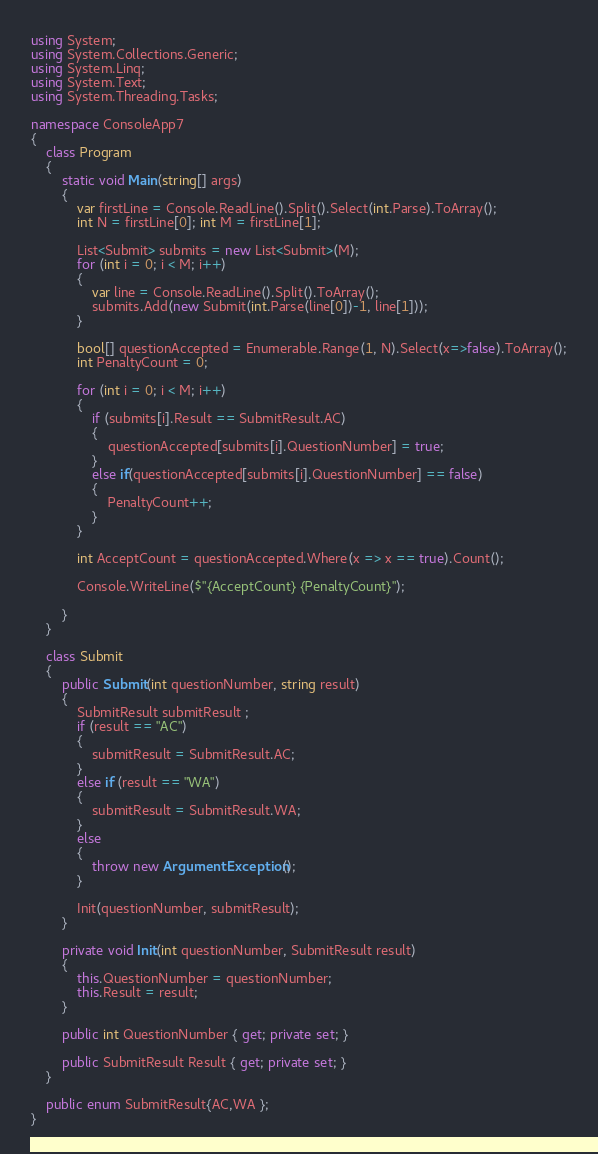<code> <loc_0><loc_0><loc_500><loc_500><_C#_>using System;
using System.Collections.Generic;
using System.Linq;
using System.Text;
using System.Threading.Tasks;

namespace ConsoleApp7
{
    class Program
    {
        static void Main(string[] args)
        {
            var firstLine = Console.ReadLine().Split().Select(int.Parse).ToArray();
            int N = firstLine[0]; int M = firstLine[1];

            List<Submit> submits = new List<Submit>(M);
            for (int i = 0; i < M; i++)
            {
                var line = Console.ReadLine().Split().ToArray();
                submits.Add(new Submit(int.Parse(line[0])-1, line[1]));
            }

            bool[] questionAccepted = Enumerable.Range(1, N).Select(x=>false).ToArray();
            int PenaltyCount = 0;

            for (int i = 0; i < M; i++)
            {
                if (submits[i].Result == SubmitResult.AC)
                {
                    questionAccepted[submits[i].QuestionNumber] = true;
                }
                else if(questionAccepted[submits[i].QuestionNumber] == false)
                {
                    PenaltyCount++;
                }
            }

            int AcceptCount = questionAccepted.Where(x => x == true).Count();

            Console.WriteLine($"{AcceptCount} {PenaltyCount}");
          
        }
    }

    class Submit
    {
        public Submit(int questionNumber, string result)
        {
            SubmitResult submitResult ;
            if (result == "AC")
            {
                submitResult = SubmitResult.AC;
            }
            else if (result == "WA")
            {
                submitResult = SubmitResult.WA;
            }
            else
            {
                throw new ArgumentException();
            }

            Init(questionNumber, submitResult);
        }

        private void Init(int questionNumber, SubmitResult result)
        {
            this.QuestionNumber = questionNumber;
            this.Result = result;
        }

        public int QuestionNumber { get; private set; }

        public SubmitResult Result { get; private set; }
    }

    public enum SubmitResult{AC,WA };
}
</code> 